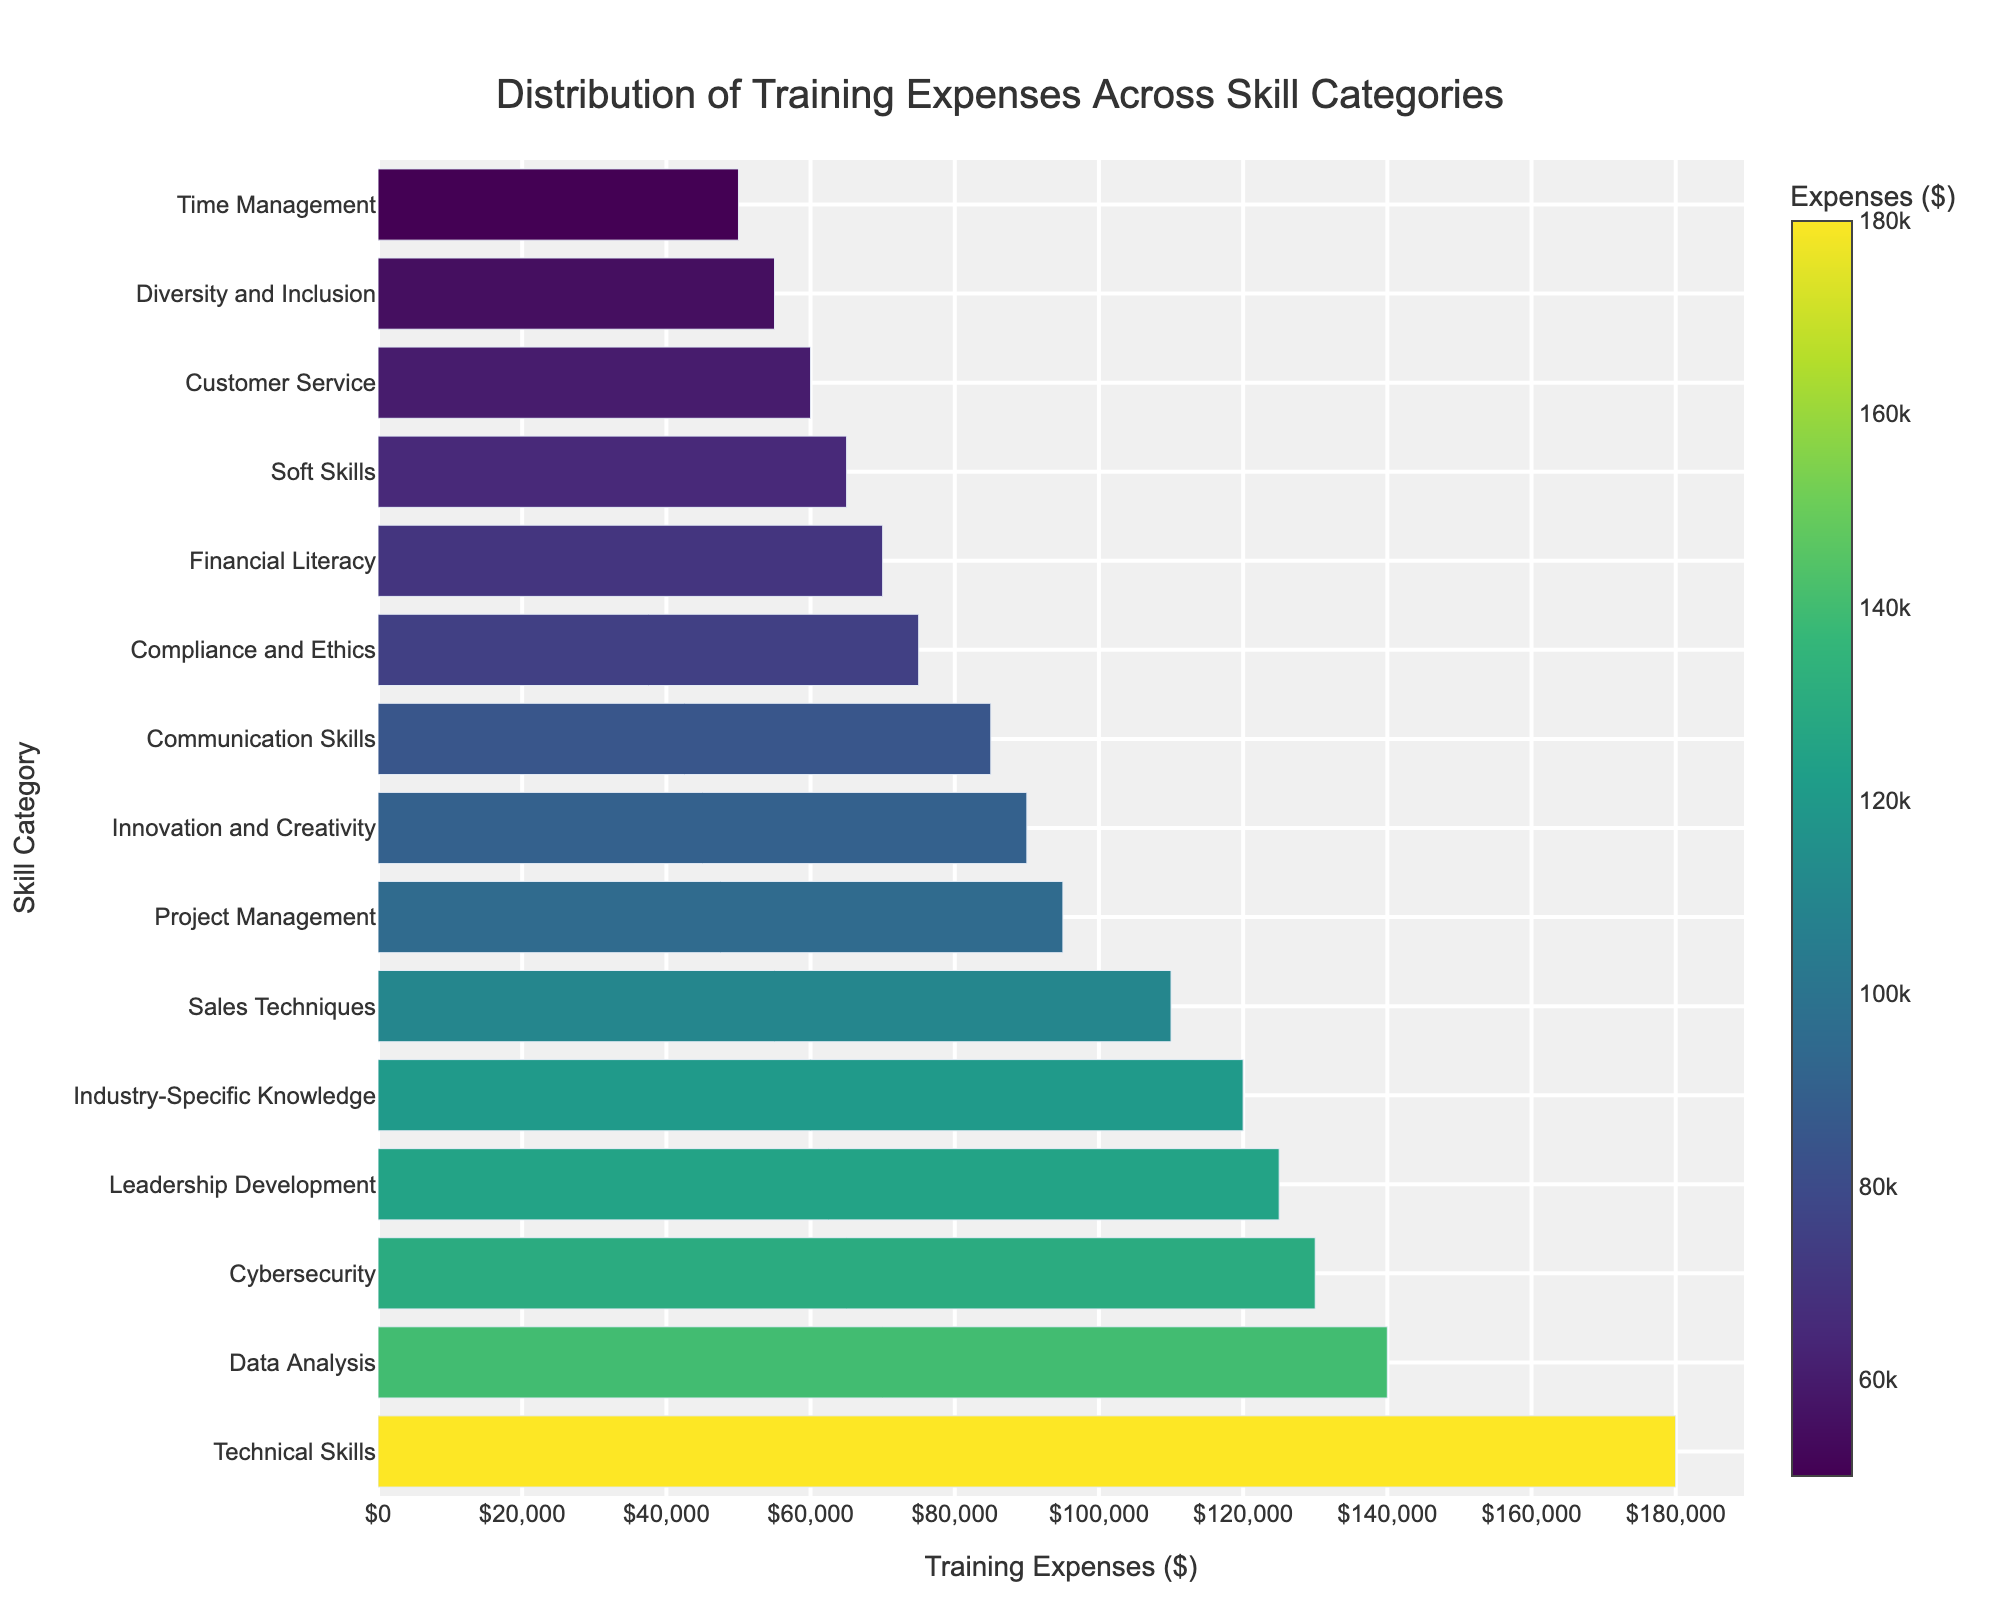What's the highest training expense for any skill category? The highest bar represents the skill category with the largest training expense. By observing visually, the longest bar corresponds to Technical Skills.
Answer: Technical Skills Which skill category has the lowest training expense? The lowest bar represents the skill category with the smallest training expense. By visual inspection, Time Management has the shortest bar.
Answer: Time Management How much more is spent on Technical Skills compared to Customer Service? Technical Skills has a training expense of $180,000 and Customer Service has $60,000. The difference is $180,000 - $60,000.
Answer: $120,000 What is the total training expense for Data Analysis and Cybersecurity combined? Data Analysis has an expense of $140,000 and Cybersecurity has $130,000. The total is $140,000 + $130,000.
Answer: $270,000 Which skill category's training expense is closest to the median value of all the expenses? To find the median training expense, first, note down all expenses and sort them. The median is in the middle of this sorted list. The sorted expenses are: $50,000, $55,000, $60,000, $65,000, $70,000, $75,000, $85,000, $90,000, $95,000, $110,000, $120,000, $125,000, $130,000, $140,000, $180,000. The median is $85,000, which is the training expense for Communication Skills.
Answer: Communication Skills Which three skill categories have training expenses above $100,000? By examining the bars, the skill categories with expenses above $100,000 are: Technical Skills ($180,000), Data Analysis ($140,000), and Leadership Development ($125,000).
Answer: Technical Skills, Data Analysis, Leadership Development What's the average training expense across all skill categories? To find the average, sum all training expenses and divide by the number of categories. ($125,000 + $180,000 + $75,000 + $95,000 + $60,000 + $110,000 + $140,000 + $85,000 + $50,000 + $70,000 + $130,000 + $65,000 + $120,000 + $55,000 + $90,000) / 15 = $135,0000 / 15.
Answer: $90,000 Which skill category has a training expense exactly in the middle between the highest and the lowest expenses? The highest training expense is $180,000 and the lowest is $50,000. The middle value (average of highest and lowest) is ($180,000 + $50,000) / 2 = $115,000. The closest training expense to $115,000 is Leadership Development, which is $125,000 (closest to $115,000 among the given values).
Answer: Leadership Development 